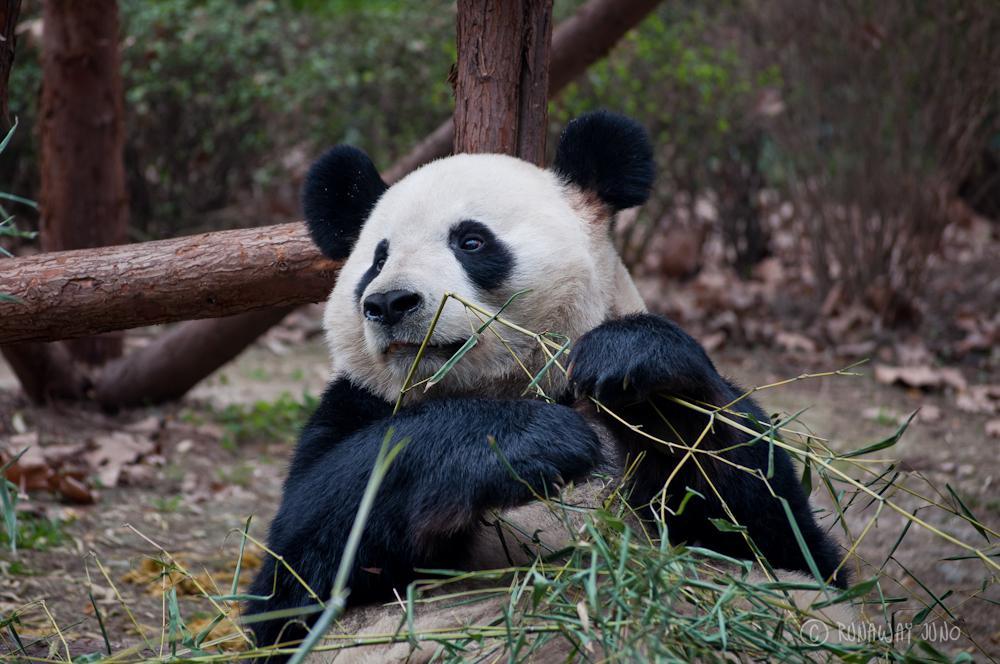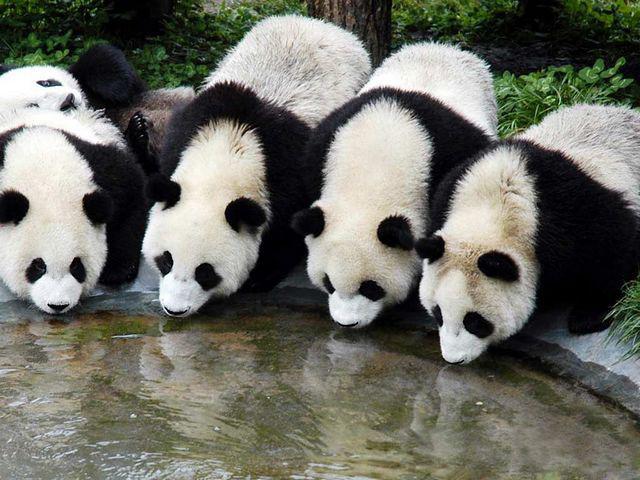The first image is the image on the left, the second image is the image on the right. For the images displayed, is the sentence "There are four pandas in the pair of images." factually correct? Answer yes or no. No. The first image is the image on the left, the second image is the image on the right. For the images shown, is this caption "There are four pandas." true? Answer yes or no. No. 